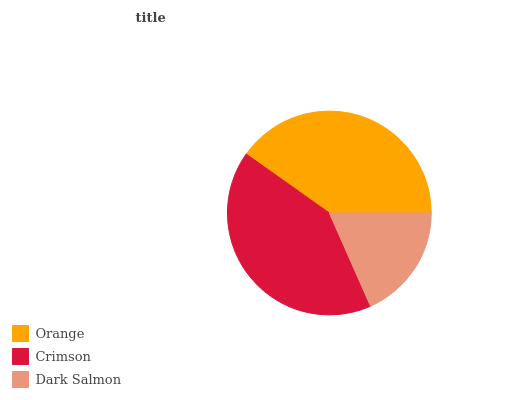Is Dark Salmon the minimum?
Answer yes or no. Yes. Is Crimson the maximum?
Answer yes or no. Yes. Is Crimson the minimum?
Answer yes or no. No. Is Dark Salmon the maximum?
Answer yes or no. No. Is Crimson greater than Dark Salmon?
Answer yes or no. Yes. Is Dark Salmon less than Crimson?
Answer yes or no. Yes. Is Dark Salmon greater than Crimson?
Answer yes or no. No. Is Crimson less than Dark Salmon?
Answer yes or no. No. Is Orange the high median?
Answer yes or no. Yes. Is Orange the low median?
Answer yes or no. Yes. Is Crimson the high median?
Answer yes or no. No. Is Dark Salmon the low median?
Answer yes or no. No. 